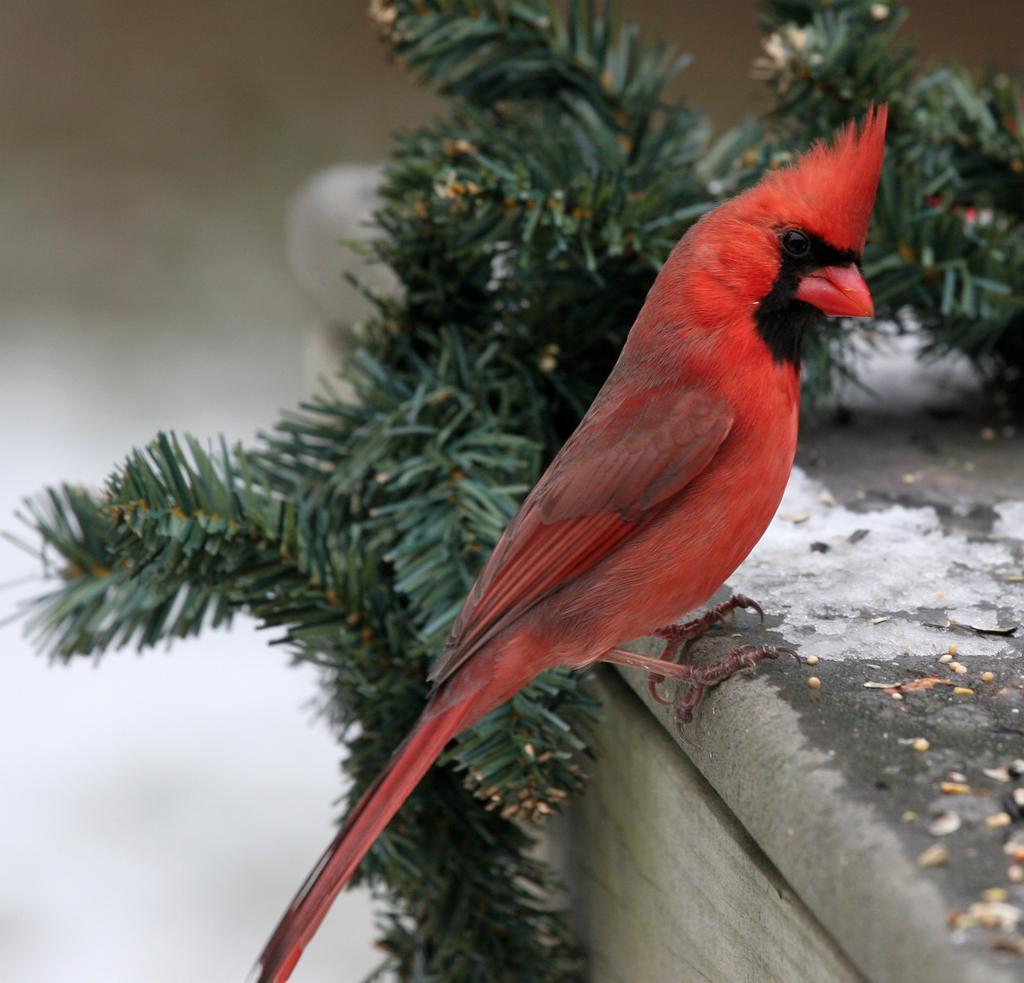Can you describe this image briefly? In this image, we can see a bird sitting on the stone, we can see green leaves. There is a blurred background. 